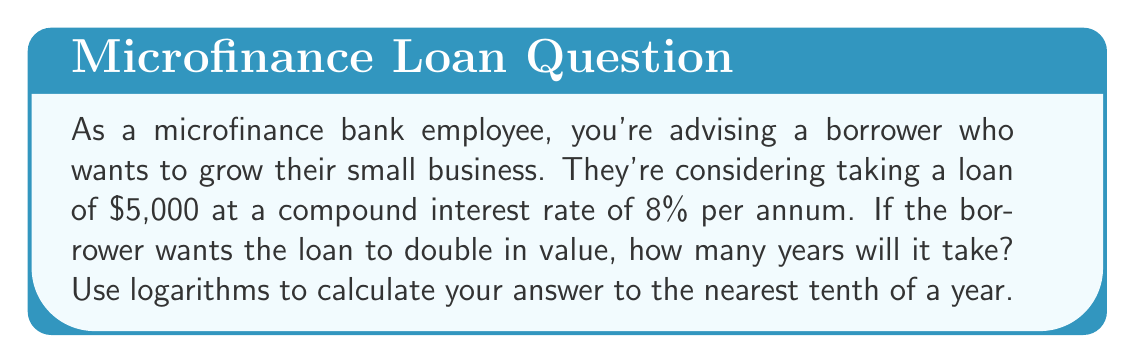Can you answer this question? To solve this problem, we'll use the compound interest formula and logarithms:

1) The compound interest formula is:
   $A = P(1 + r)^t$
   Where:
   $A$ = Final amount
   $P$ = Principal (initial investment)
   $r$ = Annual interest rate (as a decimal)
   $t$ = Time in years

2) We want the amount to double, so $A = 2P$. Let's substitute the known values:
   $2P = P(1 + 0.08)^t$

3) Simplify by dividing both sides by $P$:
   $2 = (1.08)^t$

4) To solve for $t$, we need to use logarithms. Let's apply $\log$ to both sides:
   $\log 2 = \log (1.08)^t$

5) Using the logarithm property $\log a^n = n \log a$:
   $\log 2 = t \log 1.08$

6) Now we can solve for $t$:
   $t = \frac{\log 2}{\log 1.08}$

7) Using a calculator or computer:
   $t \approx 9.006$ years

8) Rounding to the nearest tenth:
   $t \approx 9.0$ years
Answer: It will take approximately 9.0 years for the loan to double in value. 